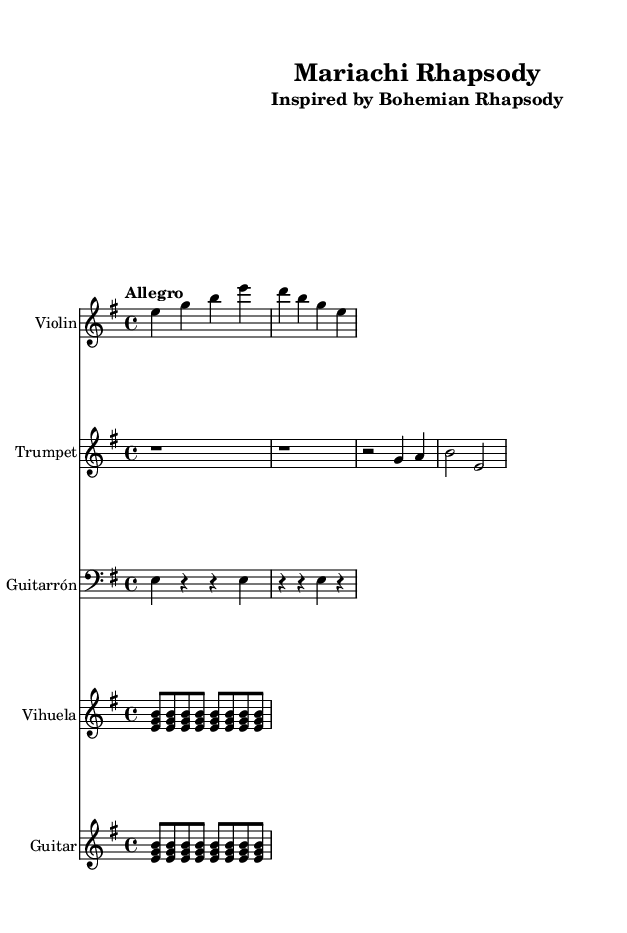What is the key signature of this music? The key signature is E minor, which has one sharp (F#). This can be deduced by looking at the key indicated in the global section of the LilyPond code, which specifies "key e minor."
Answer: E minor What is the time signature of this music? The time signature is 4/4, as indicated in the global section of the code where it states "\time 4/4." This means there are four beats in each measure.
Answer: 4/4 What is the tempo marking for this piece? The tempo marking is "Allegro," which suggests a fast, lively tempo. This is explicitly stated in the global section of the code with the line "\tempo "Allegro"."
Answer: Allegro How many instruments are featured in this music? There are five instruments featured: Violin, Trumpet, Guitarrón, Vihuela, and Guitar. This is derived from the section where each instrument is introduced with a new staff.
Answer: Five Which instrument has a rhythm pattern noted in the score? The Guitarrón has a specific rhythm pattern noted in the score as e4 r r e r r e r. This can be observed in the Guitarrón part, illustrating its rhythmic role in the composition.
Answer: Guitarrón What is the main theme this piece is inspired by? The piece is inspired by "Bohemian Rhapsody," as indicated in the subtitle of the header section. This reflects the thematic inspiration behind the arrangement.
Answer: Bohemian Rhapsody Which instruments play a steady strumming pattern? Both the Vihuela and the Guitar play a steady strumming pattern throughout the piece. This can be confirmed by examining the respective parts where they consistently strum the same chord structure.
Answer: Vihuela and Guitar 